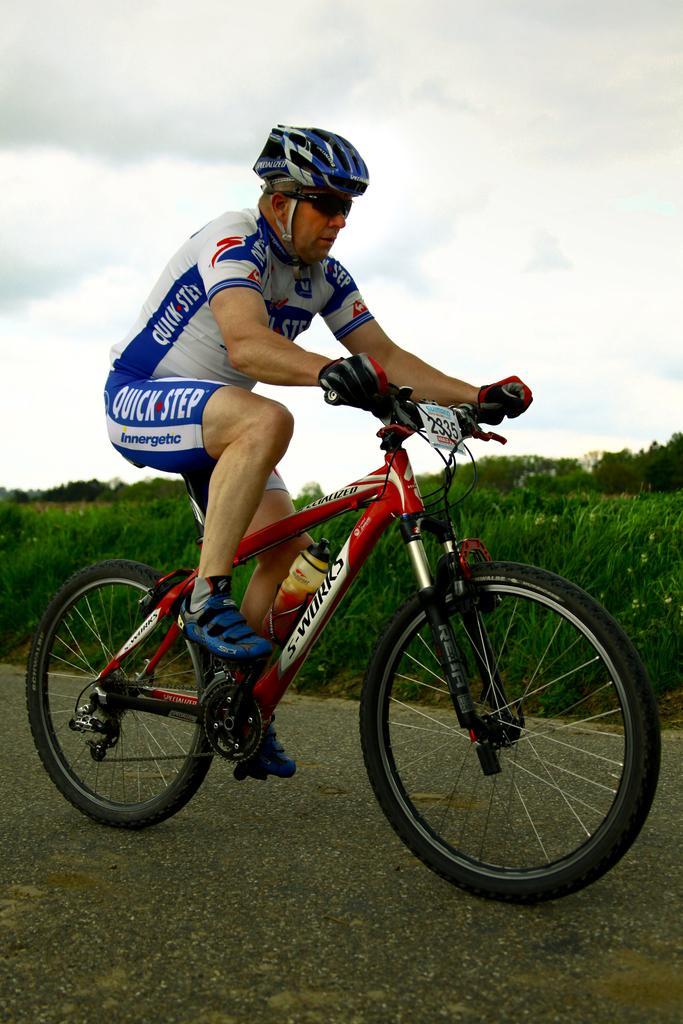How would you summarize this image in a sentence or two? In this image we can see a person wearing helmet, goggles and gloves. He is riding a cycle. On the cycle there is a number and a bottle. In the background there are trees and sky with clouds. 